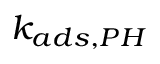Convert formula to latex. <formula><loc_0><loc_0><loc_500><loc_500>k _ { a d s , P H }</formula> 